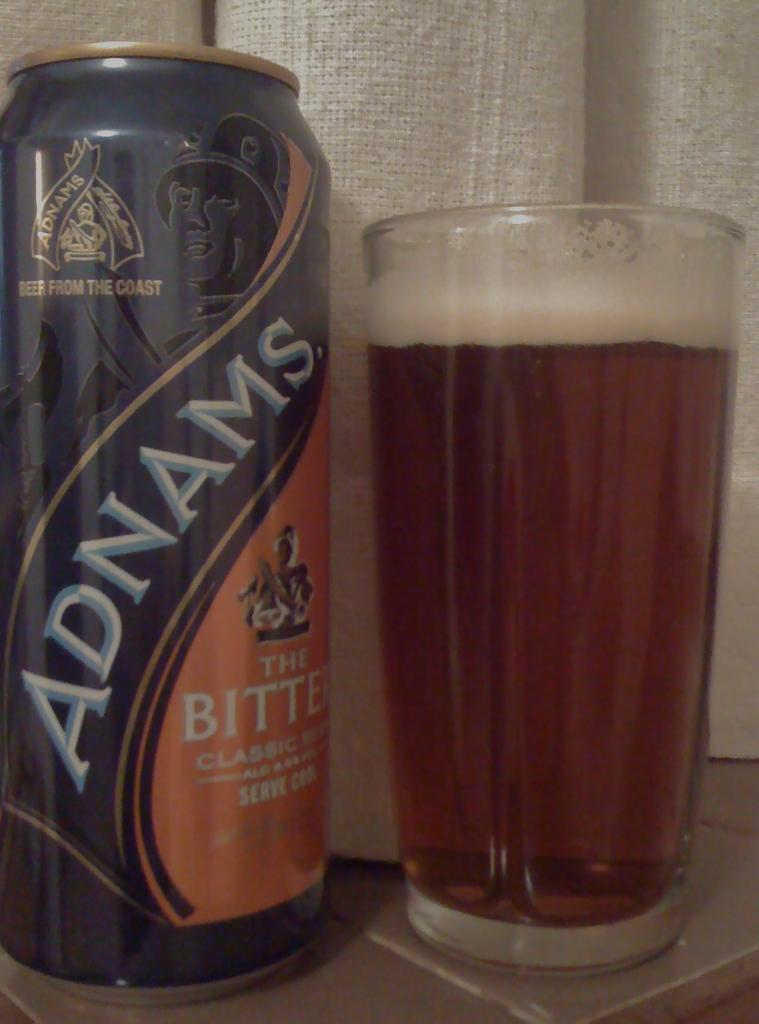What brand of beer is on the can?
Make the answer very short. Adnams. What does it say on the orange part of can?
Provide a succinct answer. The bitter. 